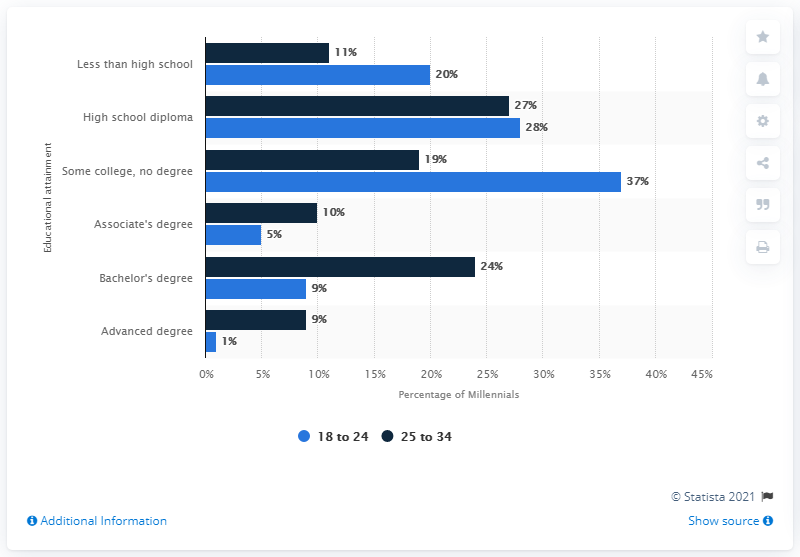Specify some key components in this picture. The age group with the highest educational attainment is 25 to 34 years old. 